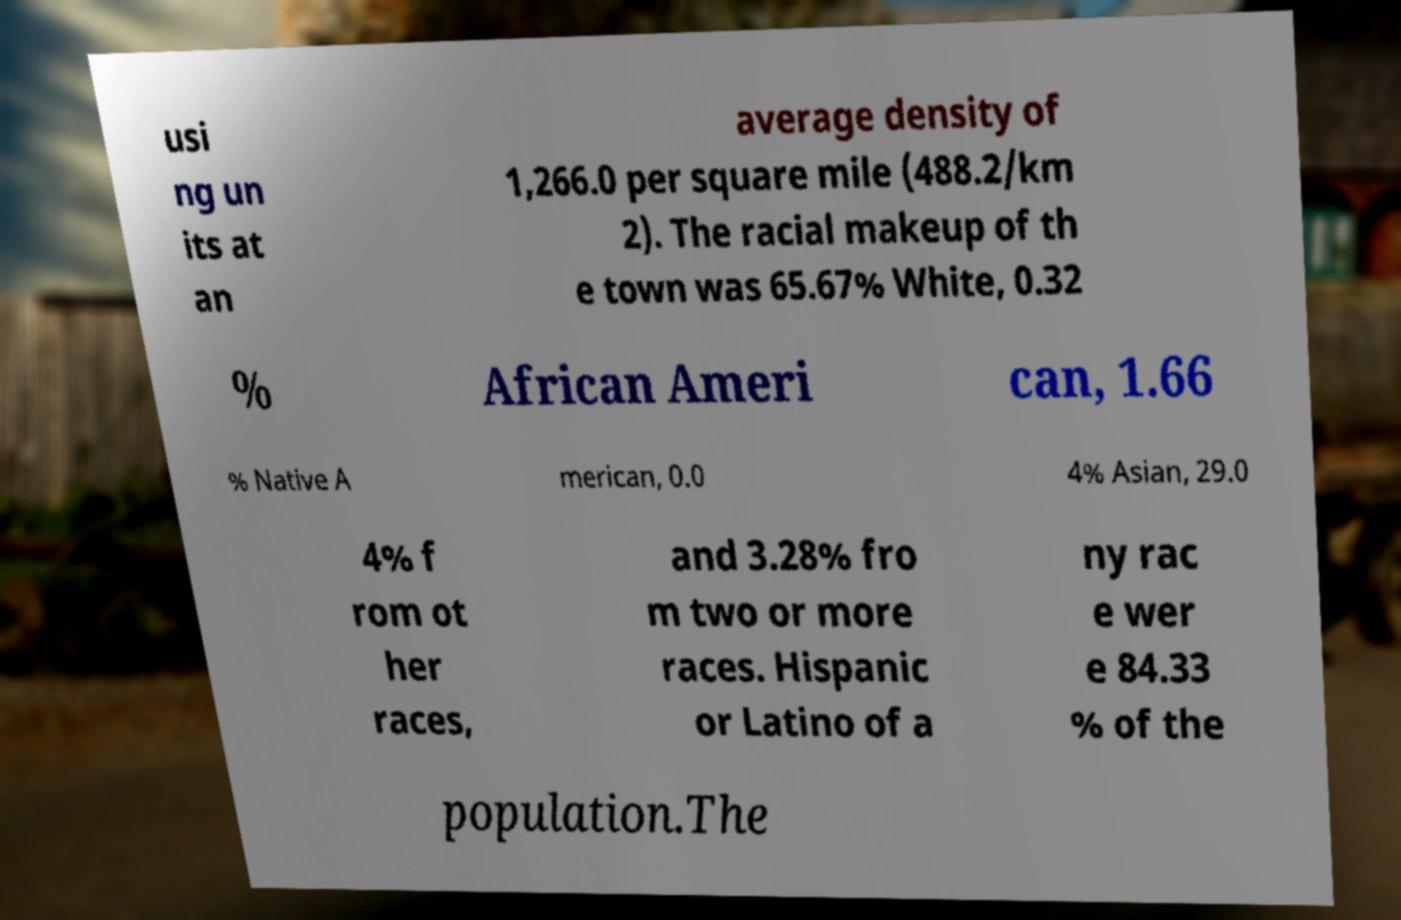For documentation purposes, I need the text within this image transcribed. Could you provide that? usi ng un its at an average density of 1,266.0 per square mile (488.2/km 2). The racial makeup of th e town was 65.67% White, 0.32 % African Ameri can, 1.66 % Native A merican, 0.0 4% Asian, 29.0 4% f rom ot her races, and 3.28% fro m two or more races. Hispanic or Latino of a ny rac e wer e 84.33 % of the population.The 